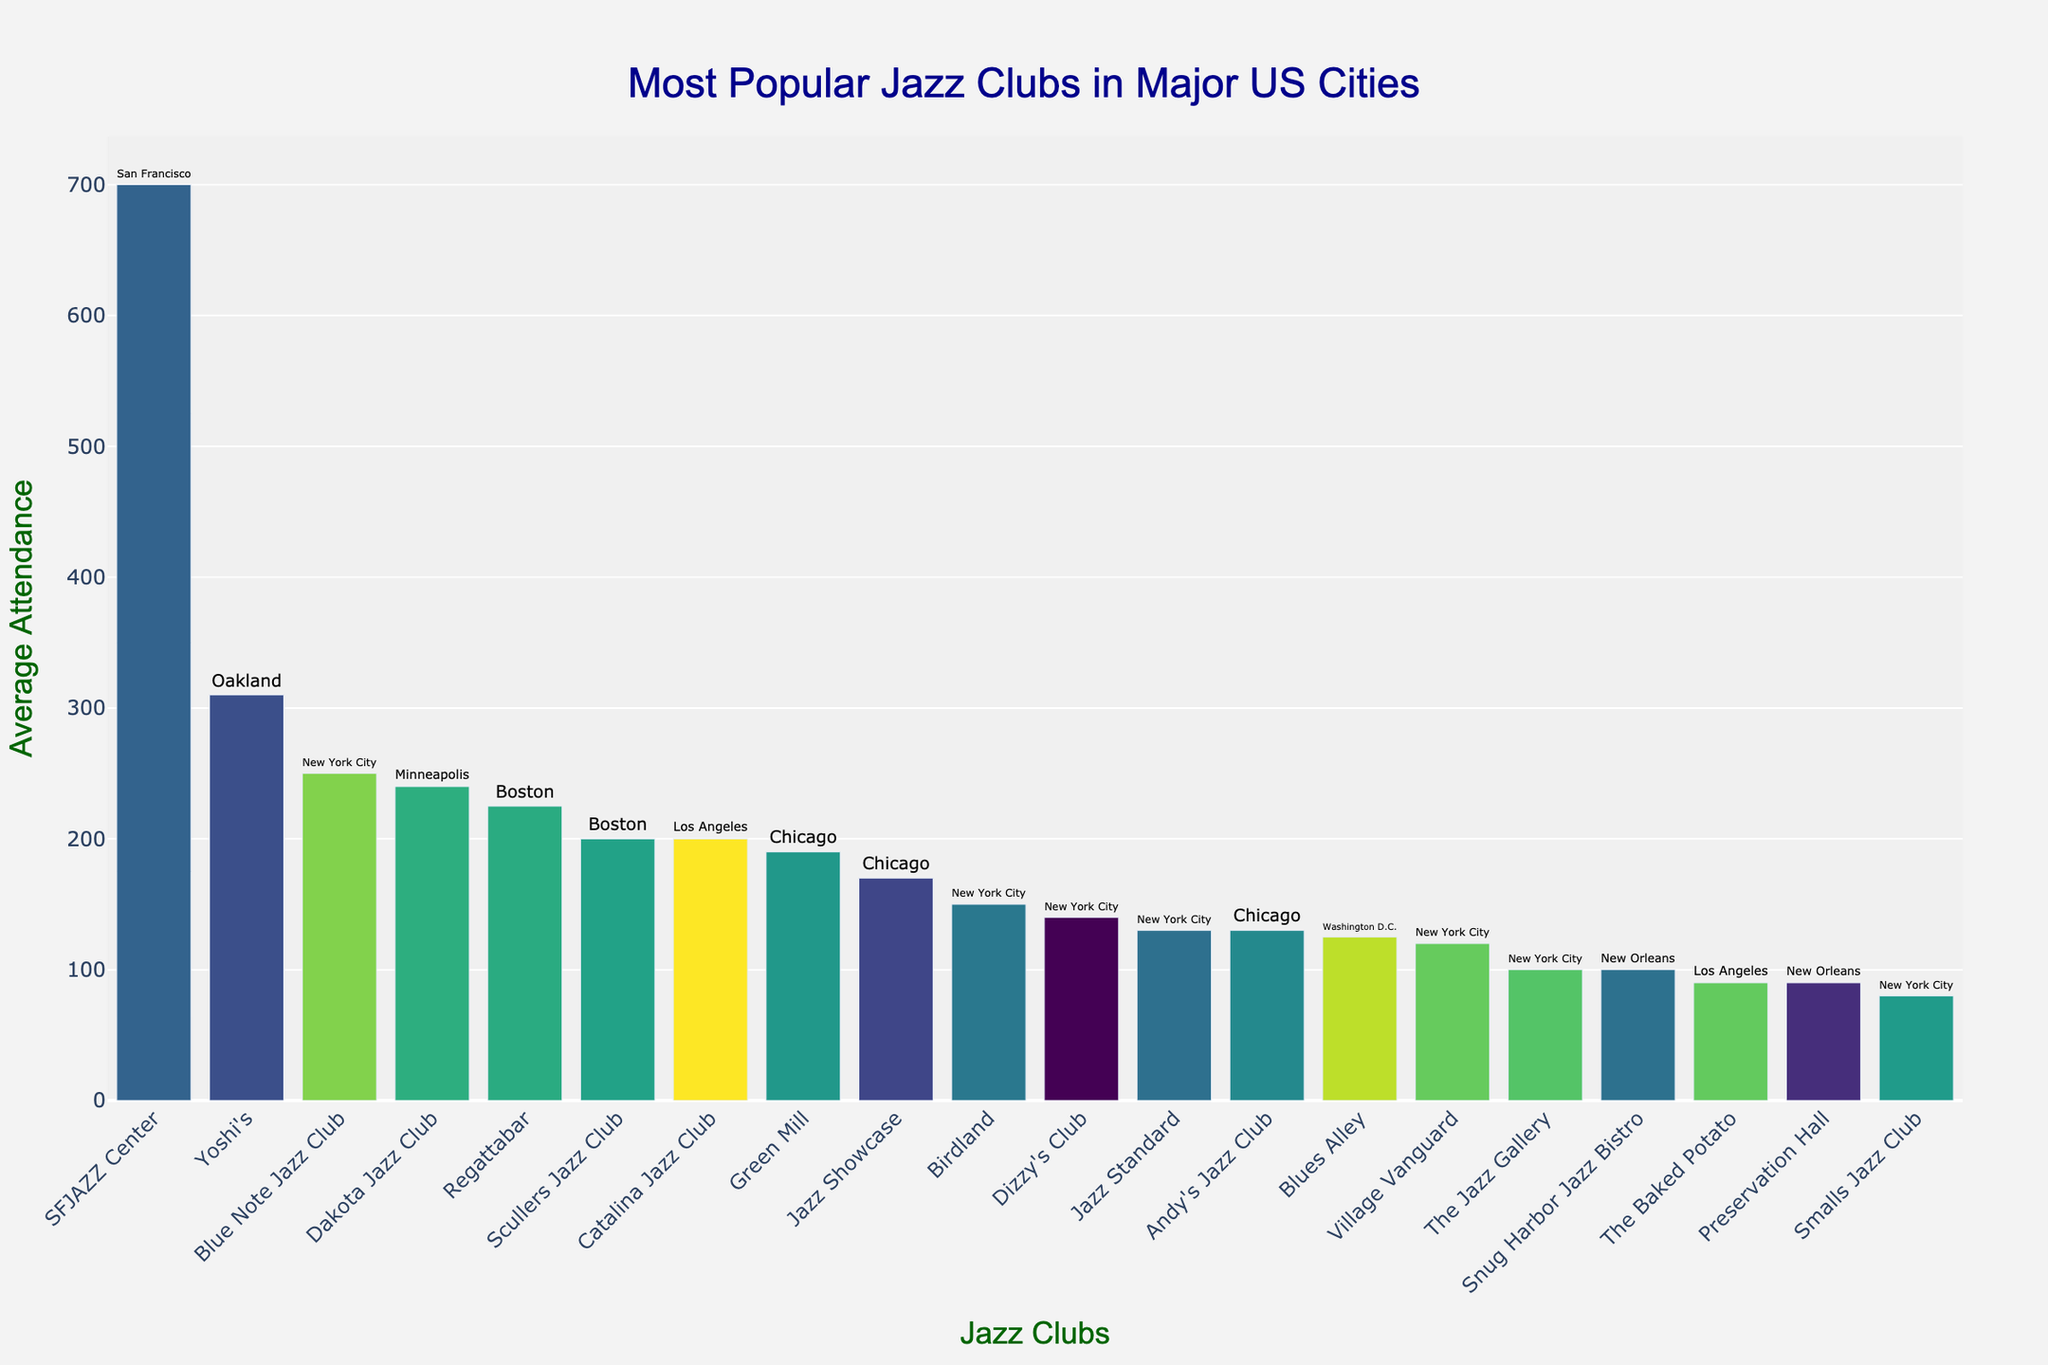What jazz club has the highest average attendance? To identify the jazz club with the highest attendance, look for the tallest bar in the chart. The bar representing SFJAZZ Center is the highest.
Answer: SFJAZZ Center Which city has the most jazz clubs listed in the chart? By counting the bars associated with each city, New York City has the most clubs listed, indicated in the text labels.
Answer: New York City What is the average attendance of the jazz clubs in Chicago? The clubs in Chicago are Green Mill, Jazz Showcase, and Andy's Jazz Club with attendance values of 190, 170, and 130, respectively. Adding these gives 490, and dividing by 3 clubs gives the average: 490/3 ≈ 163.33.
Answer: 163.33 How much higher is the average attendance of Yoshi's compared to Birdland? Yoshi's has an attendance of 310 and Birdland has 150. Subtract Birdland's attendance from Yoshi's: 310 - 150 = 160.
Answer: 160 Which club has the lowest average attendance among the New York City jazz clubs listed? Compare the bars for New York City clubs only. The shortest bar corresponds to Smalls Jazz Club with 80 attendees.
Answer: Smalls Jazz Club What is the total average attendance of the jazz clubs in Boston? Add the average attendance of Scullers Jazz Club (200) and Regattabar (225): 200 + 225 = 425.
Answer: 425 Between Dakota Jazz Club and Blue Note Jazz Club, which one has greater average attendance? Compare the bar heights for Dakota Jazz Club (Minneapolis) and Blue Note Jazz Club (New York City). The bar for Blue Note is taller with 250 compared to Dakota's 240.
Answer: Blue Note Jazz Club Is there any club with exactly 100 average attendances? If so, which one(s)? Check the height of the bars to find those corresponding to 100 average attendance. The Jazz Gallery (New York City) and Snug Harbor Jazz Bistro (New Orleans) each have a bar that represents 100 attendees.
Answer: The Jazz Gallery, Snug Harbor Jazz Bistro Which club has a higher attendance, Catalina Jazz Club or Regattabar? Compare the heights of the bars for Catalina Jazz Club (Los Angeles) and Regattabar (Boston). Regattabar has a taller bar with 225, whereas Catalina has 200.
Answer: Regattabar How many jazz clubs have an average attendance of over 200? Identify all bars exceeding the 200 mark. These clubs are Regattabar (225), Yoshi's (310), and SFJAZZ Center (700), so there are 3 clubs.
Answer: 3 